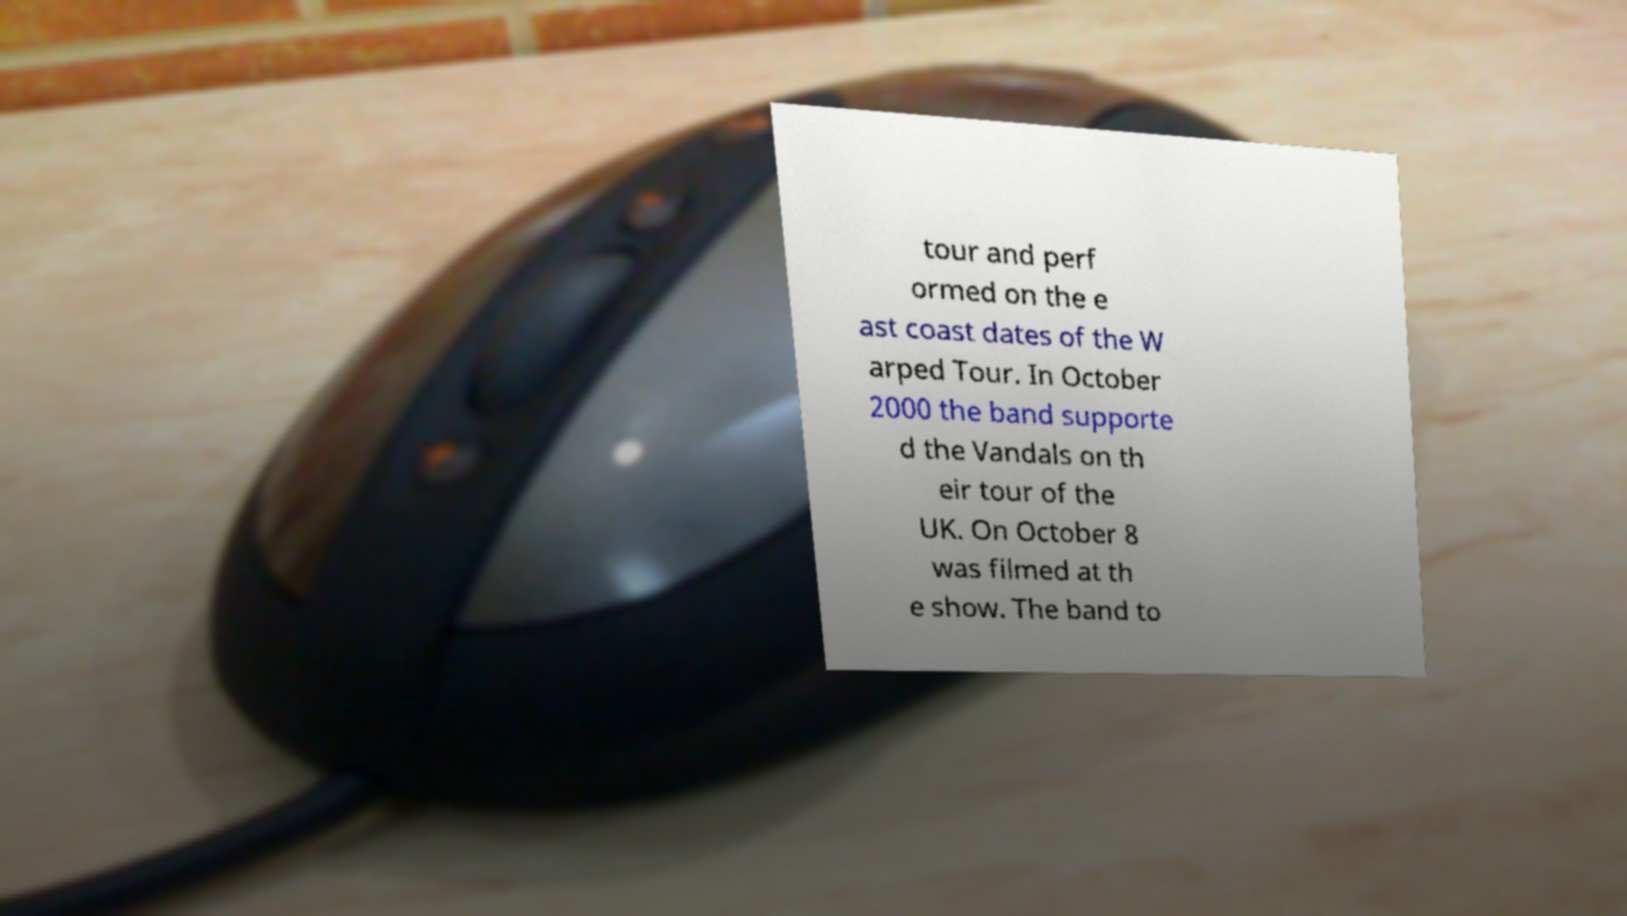Can you read and provide the text displayed in the image?This photo seems to have some interesting text. Can you extract and type it out for me? tour and perf ormed on the e ast coast dates of the W arped Tour. In October 2000 the band supporte d the Vandals on th eir tour of the UK. On October 8 was filmed at th e show. The band to 